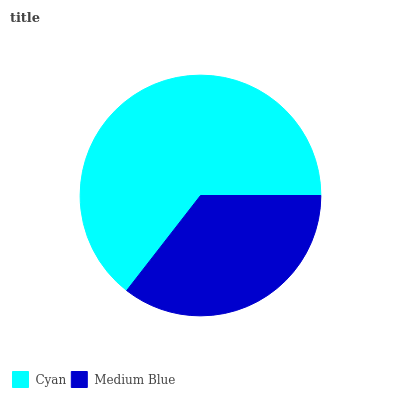Is Medium Blue the minimum?
Answer yes or no. Yes. Is Cyan the maximum?
Answer yes or no. Yes. Is Medium Blue the maximum?
Answer yes or no. No. Is Cyan greater than Medium Blue?
Answer yes or no. Yes. Is Medium Blue less than Cyan?
Answer yes or no. Yes. Is Medium Blue greater than Cyan?
Answer yes or no. No. Is Cyan less than Medium Blue?
Answer yes or no. No. Is Cyan the high median?
Answer yes or no. Yes. Is Medium Blue the low median?
Answer yes or no. Yes. Is Medium Blue the high median?
Answer yes or no. No. Is Cyan the low median?
Answer yes or no. No. 